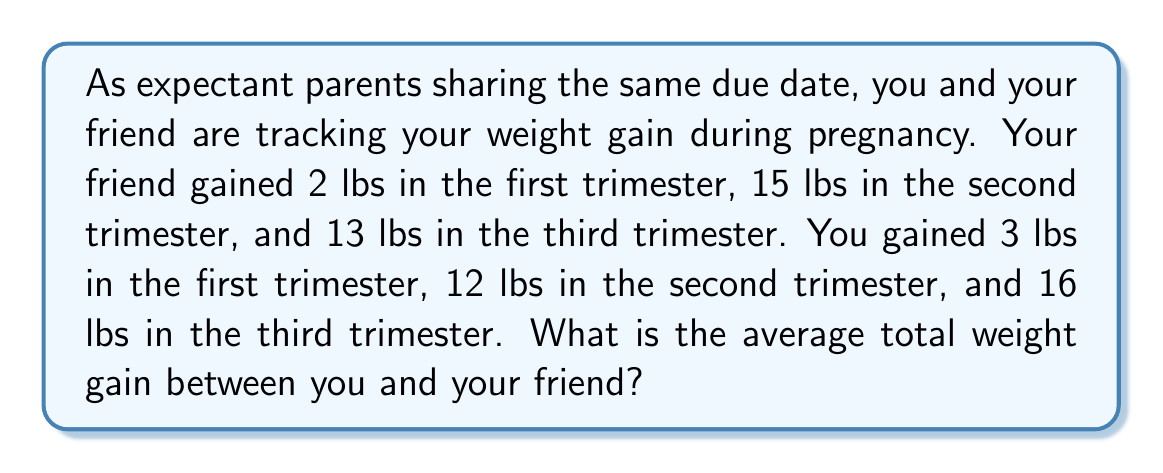What is the answer to this math problem? To solve this problem, we'll follow these steps:

1. Calculate the total weight gain for each person:
   Friend: $2 + 15 + 13 = 30$ lbs
   You: $3 + 12 + 16 = 31$ lbs

2. Add the total weight gain of both people:
   $30 + 31 = 61$ lbs

3. Calculate the average by dividing the sum by the number of people (2):
   $$\text{Average} = \frac{\text{Sum of values}}{\text{Number of values}} = \frac{61}{2} = 30.5\text{ lbs}$$

Therefore, the average total weight gain between you and your friend during pregnancy is 30.5 lbs.
Answer: $30.5\text{ lbs}$ 